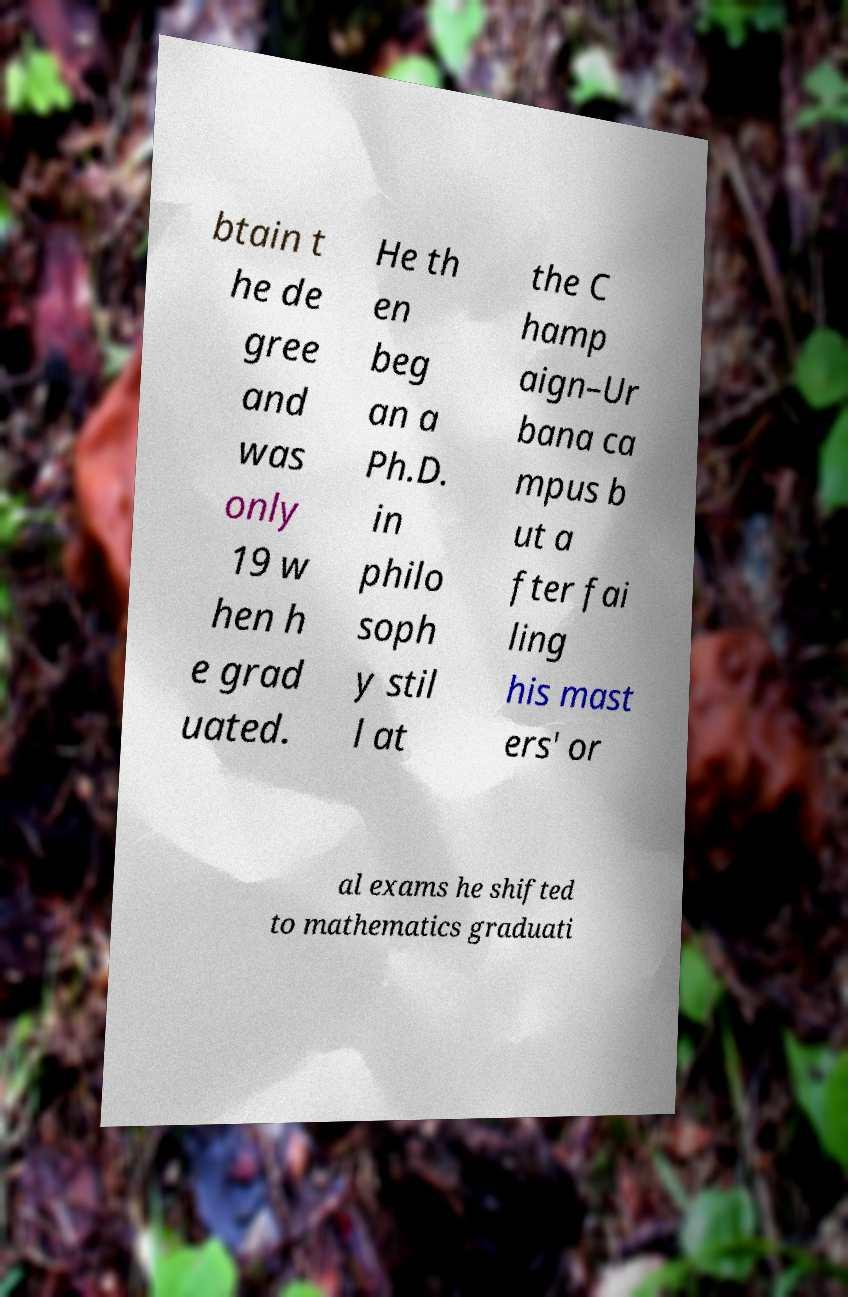What messages or text are displayed in this image? I need them in a readable, typed format. btain t he de gree and was only 19 w hen h e grad uated. He th en beg an a Ph.D. in philo soph y stil l at the C hamp aign–Ur bana ca mpus b ut a fter fai ling his mast ers' or al exams he shifted to mathematics graduati 